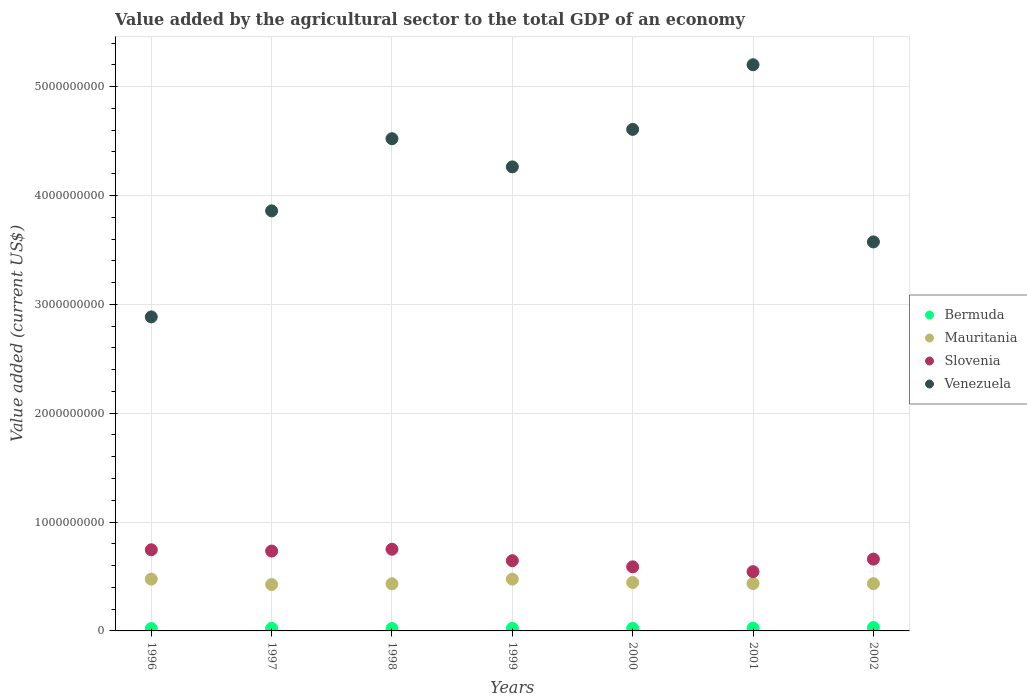What is the value added by the agricultural sector to the total GDP in Venezuela in 1997?
Your answer should be compact. 3.86e+09. Across all years, what is the maximum value added by the agricultural sector to the total GDP in Bermuda?
Your answer should be compact. 3.13e+07. Across all years, what is the minimum value added by the agricultural sector to the total GDP in Mauritania?
Make the answer very short. 4.26e+08. In which year was the value added by the agricultural sector to the total GDP in Bermuda minimum?
Keep it short and to the point. 1996. What is the total value added by the agricultural sector to the total GDP in Mauritania in the graph?
Provide a succinct answer. 3.12e+09. What is the difference between the value added by the agricultural sector to the total GDP in Venezuela in 2000 and that in 2001?
Make the answer very short. -5.94e+08. What is the difference between the value added by the agricultural sector to the total GDP in Bermuda in 2002 and the value added by the agricultural sector to the total GDP in Mauritania in 2000?
Your answer should be compact. -4.13e+08. What is the average value added by the agricultural sector to the total GDP in Bermuda per year?
Your response must be concise. 2.43e+07. In the year 1996, what is the difference between the value added by the agricultural sector to the total GDP in Mauritania and value added by the agricultural sector to the total GDP in Slovenia?
Your answer should be very brief. -2.69e+08. In how many years, is the value added by the agricultural sector to the total GDP in Venezuela greater than 2200000000 US$?
Your response must be concise. 7. What is the ratio of the value added by the agricultural sector to the total GDP in Slovenia in 1997 to that in 2000?
Your answer should be compact. 1.25. Is the value added by the agricultural sector to the total GDP in Mauritania in 2000 less than that in 2002?
Offer a very short reply. No. What is the difference between the highest and the second highest value added by the agricultural sector to the total GDP in Venezuela?
Ensure brevity in your answer.  5.94e+08. What is the difference between the highest and the lowest value added by the agricultural sector to the total GDP in Bermuda?
Make the answer very short. 9.76e+06. Is the sum of the value added by the agricultural sector to the total GDP in Mauritania in 1998 and 2001 greater than the maximum value added by the agricultural sector to the total GDP in Slovenia across all years?
Provide a succinct answer. Yes. Is it the case that in every year, the sum of the value added by the agricultural sector to the total GDP in Bermuda and value added by the agricultural sector to the total GDP in Mauritania  is greater than the sum of value added by the agricultural sector to the total GDP in Venezuela and value added by the agricultural sector to the total GDP in Slovenia?
Your response must be concise. No. Is it the case that in every year, the sum of the value added by the agricultural sector to the total GDP in Venezuela and value added by the agricultural sector to the total GDP in Slovenia  is greater than the value added by the agricultural sector to the total GDP in Mauritania?
Make the answer very short. Yes. Does the value added by the agricultural sector to the total GDP in Bermuda monotonically increase over the years?
Make the answer very short. No. Is the value added by the agricultural sector to the total GDP in Slovenia strictly greater than the value added by the agricultural sector to the total GDP in Bermuda over the years?
Provide a succinct answer. Yes. How many years are there in the graph?
Give a very brief answer. 7. What is the difference between two consecutive major ticks on the Y-axis?
Offer a very short reply. 1.00e+09. Does the graph contain grids?
Your answer should be very brief. Yes. What is the title of the graph?
Provide a succinct answer. Value added by the agricultural sector to the total GDP of an economy. What is the label or title of the Y-axis?
Your response must be concise. Value added (current US$). What is the Value added (current US$) of Bermuda in 1996?
Provide a succinct answer. 2.16e+07. What is the Value added (current US$) of Mauritania in 1996?
Your answer should be very brief. 4.76e+08. What is the Value added (current US$) of Slovenia in 1996?
Your answer should be very brief. 7.45e+08. What is the Value added (current US$) in Venezuela in 1996?
Ensure brevity in your answer.  2.88e+09. What is the Value added (current US$) of Bermuda in 1997?
Your response must be concise. 2.35e+07. What is the Value added (current US$) of Mauritania in 1997?
Provide a succinct answer. 4.26e+08. What is the Value added (current US$) in Slovenia in 1997?
Offer a terse response. 7.34e+08. What is the Value added (current US$) in Venezuela in 1997?
Your answer should be compact. 3.86e+09. What is the Value added (current US$) of Bermuda in 1998?
Ensure brevity in your answer.  2.19e+07. What is the Value added (current US$) of Mauritania in 1998?
Ensure brevity in your answer.  4.33e+08. What is the Value added (current US$) of Slovenia in 1998?
Offer a terse response. 7.50e+08. What is the Value added (current US$) in Venezuela in 1998?
Your answer should be compact. 4.52e+09. What is the Value added (current US$) of Bermuda in 1999?
Your answer should be compact. 2.33e+07. What is the Value added (current US$) in Mauritania in 1999?
Keep it short and to the point. 4.76e+08. What is the Value added (current US$) of Slovenia in 1999?
Your answer should be compact. 6.45e+08. What is the Value added (current US$) of Venezuela in 1999?
Your response must be concise. 4.26e+09. What is the Value added (current US$) in Bermuda in 2000?
Give a very brief answer. 2.33e+07. What is the Value added (current US$) of Mauritania in 2000?
Offer a terse response. 4.45e+08. What is the Value added (current US$) in Slovenia in 2000?
Your answer should be compact. 5.89e+08. What is the Value added (current US$) in Venezuela in 2000?
Your answer should be very brief. 4.61e+09. What is the Value added (current US$) in Bermuda in 2001?
Provide a succinct answer. 2.55e+07. What is the Value added (current US$) of Mauritania in 2001?
Your answer should be compact. 4.35e+08. What is the Value added (current US$) of Slovenia in 2001?
Provide a short and direct response. 5.44e+08. What is the Value added (current US$) of Venezuela in 2001?
Ensure brevity in your answer.  5.20e+09. What is the Value added (current US$) in Bermuda in 2002?
Offer a terse response. 3.13e+07. What is the Value added (current US$) in Mauritania in 2002?
Your response must be concise. 4.34e+08. What is the Value added (current US$) in Slovenia in 2002?
Keep it short and to the point. 6.60e+08. What is the Value added (current US$) of Venezuela in 2002?
Offer a very short reply. 3.57e+09. Across all years, what is the maximum Value added (current US$) in Bermuda?
Provide a short and direct response. 3.13e+07. Across all years, what is the maximum Value added (current US$) in Mauritania?
Your response must be concise. 4.76e+08. Across all years, what is the maximum Value added (current US$) in Slovenia?
Provide a succinct answer. 7.50e+08. Across all years, what is the maximum Value added (current US$) in Venezuela?
Offer a very short reply. 5.20e+09. Across all years, what is the minimum Value added (current US$) in Bermuda?
Provide a short and direct response. 2.16e+07. Across all years, what is the minimum Value added (current US$) in Mauritania?
Your response must be concise. 4.26e+08. Across all years, what is the minimum Value added (current US$) of Slovenia?
Your answer should be compact. 5.44e+08. Across all years, what is the minimum Value added (current US$) in Venezuela?
Offer a very short reply. 2.88e+09. What is the total Value added (current US$) of Bermuda in the graph?
Ensure brevity in your answer.  1.70e+08. What is the total Value added (current US$) of Mauritania in the graph?
Keep it short and to the point. 3.12e+09. What is the total Value added (current US$) in Slovenia in the graph?
Give a very brief answer. 4.67e+09. What is the total Value added (current US$) of Venezuela in the graph?
Give a very brief answer. 2.89e+1. What is the difference between the Value added (current US$) of Bermuda in 1996 and that in 1997?
Your answer should be very brief. -1.90e+06. What is the difference between the Value added (current US$) of Mauritania in 1996 and that in 1997?
Ensure brevity in your answer.  5.00e+07. What is the difference between the Value added (current US$) in Slovenia in 1996 and that in 1997?
Give a very brief answer. 1.16e+07. What is the difference between the Value added (current US$) in Venezuela in 1996 and that in 1997?
Offer a very short reply. -9.74e+08. What is the difference between the Value added (current US$) in Bermuda in 1996 and that in 1998?
Give a very brief answer. -3.52e+05. What is the difference between the Value added (current US$) in Mauritania in 1996 and that in 1998?
Your answer should be very brief. 4.32e+07. What is the difference between the Value added (current US$) of Slovenia in 1996 and that in 1998?
Make the answer very short. -5.19e+06. What is the difference between the Value added (current US$) in Venezuela in 1996 and that in 1998?
Your answer should be very brief. -1.64e+09. What is the difference between the Value added (current US$) in Bermuda in 1996 and that in 1999?
Offer a very short reply. -1.71e+06. What is the difference between the Value added (current US$) of Mauritania in 1996 and that in 1999?
Ensure brevity in your answer.  5.43e+05. What is the difference between the Value added (current US$) of Slovenia in 1996 and that in 1999?
Offer a very short reply. 1.00e+08. What is the difference between the Value added (current US$) of Venezuela in 1996 and that in 1999?
Offer a very short reply. -1.38e+09. What is the difference between the Value added (current US$) in Bermuda in 1996 and that in 2000?
Provide a succinct answer. -1.72e+06. What is the difference between the Value added (current US$) of Mauritania in 1996 and that in 2000?
Provide a succinct answer. 3.15e+07. What is the difference between the Value added (current US$) of Slovenia in 1996 and that in 2000?
Offer a very short reply. 1.57e+08. What is the difference between the Value added (current US$) of Venezuela in 1996 and that in 2000?
Give a very brief answer. -1.72e+09. What is the difference between the Value added (current US$) of Bermuda in 1996 and that in 2001?
Your answer should be very brief. -3.92e+06. What is the difference between the Value added (current US$) in Mauritania in 1996 and that in 2001?
Give a very brief answer. 4.09e+07. What is the difference between the Value added (current US$) in Slovenia in 1996 and that in 2001?
Offer a very short reply. 2.01e+08. What is the difference between the Value added (current US$) of Venezuela in 1996 and that in 2001?
Your answer should be compact. -2.32e+09. What is the difference between the Value added (current US$) of Bermuda in 1996 and that in 2002?
Provide a short and direct response. -9.76e+06. What is the difference between the Value added (current US$) of Mauritania in 1996 and that in 2002?
Make the answer very short. 4.19e+07. What is the difference between the Value added (current US$) of Slovenia in 1996 and that in 2002?
Your answer should be very brief. 8.56e+07. What is the difference between the Value added (current US$) of Venezuela in 1996 and that in 2002?
Your answer should be very brief. -6.89e+08. What is the difference between the Value added (current US$) of Bermuda in 1997 and that in 1998?
Make the answer very short. 1.55e+06. What is the difference between the Value added (current US$) in Mauritania in 1997 and that in 1998?
Give a very brief answer. -6.77e+06. What is the difference between the Value added (current US$) of Slovenia in 1997 and that in 1998?
Give a very brief answer. -1.68e+07. What is the difference between the Value added (current US$) of Venezuela in 1997 and that in 1998?
Your response must be concise. -6.63e+08. What is the difference between the Value added (current US$) in Bermuda in 1997 and that in 1999?
Offer a terse response. 1.92e+05. What is the difference between the Value added (current US$) of Mauritania in 1997 and that in 1999?
Offer a terse response. -4.95e+07. What is the difference between the Value added (current US$) of Slovenia in 1997 and that in 1999?
Offer a very short reply. 8.85e+07. What is the difference between the Value added (current US$) of Venezuela in 1997 and that in 1999?
Keep it short and to the point. -4.04e+08. What is the difference between the Value added (current US$) in Bermuda in 1997 and that in 2000?
Ensure brevity in your answer.  1.82e+05. What is the difference between the Value added (current US$) in Mauritania in 1997 and that in 2000?
Give a very brief answer. -1.85e+07. What is the difference between the Value added (current US$) in Slovenia in 1997 and that in 2000?
Provide a succinct answer. 1.45e+08. What is the difference between the Value added (current US$) in Venezuela in 1997 and that in 2000?
Your response must be concise. -7.49e+08. What is the difference between the Value added (current US$) of Bermuda in 1997 and that in 2001?
Provide a short and direct response. -2.02e+06. What is the difference between the Value added (current US$) in Mauritania in 1997 and that in 2001?
Make the answer very short. -9.14e+06. What is the difference between the Value added (current US$) of Slovenia in 1997 and that in 2001?
Give a very brief answer. 1.89e+08. What is the difference between the Value added (current US$) of Venezuela in 1997 and that in 2001?
Your response must be concise. -1.34e+09. What is the difference between the Value added (current US$) of Bermuda in 1997 and that in 2002?
Your answer should be compact. -7.86e+06. What is the difference between the Value added (current US$) of Mauritania in 1997 and that in 2002?
Your answer should be compact. -8.09e+06. What is the difference between the Value added (current US$) in Slovenia in 1997 and that in 2002?
Give a very brief answer. 7.40e+07. What is the difference between the Value added (current US$) in Venezuela in 1997 and that in 2002?
Your answer should be very brief. 2.85e+08. What is the difference between the Value added (current US$) in Bermuda in 1998 and that in 1999?
Your response must be concise. -1.36e+06. What is the difference between the Value added (current US$) of Mauritania in 1998 and that in 1999?
Provide a succinct answer. -4.27e+07. What is the difference between the Value added (current US$) in Slovenia in 1998 and that in 1999?
Your response must be concise. 1.05e+08. What is the difference between the Value added (current US$) in Venezuela in 1998 and that in 1999?
Keep it short and to the point. 2.59e+08. What is the difference between the Value added (current US$) in Bermuda in 1998 and that in 2000?
Ensure brevity in your answer.  -1.37e+06. What is the difference between the Value added (current US$) in Mauritania in 1998 and that in 2000?
Give a very brief answer. -1.18e+07. What is the difference between the Value added (current US$) of Slovenia in 1998 and that in 2000?
Ensure brevity in your answer.  1.62e+08. What is the difference between the Value added (current US$) of Venezuela in 1998 and that in 2000?
Keep it short and to the point. -8.57e+07. What is the difference between the Value added (current US$) of Bermuda in 1998 and that in 2001?
Offer a very short reply. -3.57e+06. What is the difference between the Value added (current US$) of Mauritania in 1998 and that in 2001?
Provide a short and direct response. -2.37e+06. What is the difference between the Value added (current US$) in Slovenia in 1998 and that in 2001?
Make the answer very short. 2.06e+08. What is the difference between the Value added (current US$) in Venezuela in 1998 and that in 2001?
Offer a very short reply. -6.79e+08. What is the difference between the Value added (current US$) in Bermuda in 1998 and that in 2002?
Offer a terse response. -9.40e+06. What is the difference between the Value added (current US$) in Mauritania in 1998 and that in 2002?
Your response must be concise. -1.32e+06. What is the difference between the Value added (current US$) of Slovenia in 1998 and that in 2002?
Ensure brevity in your answer.  9.08e+07. What is the difference between the Value added (current US$) in Venezuela in 1998 and that in 2002?
Make the answer very short. 9.48e+08. What is the difference between the Value added (current US$) in Bermuda in 1999 and that in 2000?
Your answer should be very brief. -9969. What is the difference between the Value added (current US$) in Mauritania in 1999 and that in 2000?
Provide a short and direct response. 3.09e+07. What is the difference between the Value added (current US$) in Slovenia in 1999 and that in 2000?
Offer a terse response. 5.65e+07. What is the difference between the Value added (current US$) of Venezuela in 1999 and that in 2000?
Offer a very short reply. -3.44e+08. What is the difference between the Value added (current US$) of Bermuda in 1999 and that in 2001?
Make the answer very short. -2.21e+06. What is the difference between the Value added (current US$) of Mauritania in 1999 and that in 2001?
Offer a very short reply. 4.03e+07. What is the difference between the Value added (current US$) of Slovenia in 1999 and that in 2001?
Provide a succinct answer. 1.01e+08. What is the difference between the Value added (current US$) in Venezuela in 1999 and that in 2001?
Ensure brevity in your answer.  -9.38e+08. What is the difference between the Value added (current US$) in Bermuda in 1999 and that in 2002?
Provide a succinct answer. -8.05e+06. What is the difference between the Value added (current US$) of Mauritania in 1999 and that in 2002?
Your response must be concise. 4.14e+07. What is the difference between the Value added (current US$) of Slovenia in 1999 and that in 2002?
Offer a very short reply. -1.45e+07. What is the difference between the Value added (current US$) in Venezuela in 1999 and that in 2002?
Your response must be concise. 6.89e+08. What is the difference between the Value added (current US$) of Bermuda in 2000 and that in 2001?
Give a very brief answer. -2.20e+06. What is the difference between the Value added (current US$) in Mauritania in 2000 and that in 2001?
Offer a very short reply. 9.40e+06. What is the difference between the Value added (current US$) of Slovenia in 2000 and that in 2001?
Keep it short and to the point. 4.43e+07. What is the difference between the Value added (current US$) of Venezuela in 2000 and that in 2001?
Offer a very short reply. -5.94e+08. What is the difference between the Value added (current US$) of Bermuda in 2000 and that in 2002?
Your answer should be very brief. -8.04e+06. What is the difference between the Value added (current US$) in Mauritania in 2000 and that in 2002?
Keep it short and to the point. 1.04e+07. What is the difference between the Value added (current US$) of Slovenia in 2000 and that in 2002?
Your answer should be very brief. -7.10e+07. What is the difference between the Value added (current US$) of Venezuela in 2000 and that in 2002?
Provide a short and direct response. 1.03e+09. What is the difference between the Value added (current US$) of Bermuda in 2001 and that in 2002?
Your response must be concise. -5.84e+06. What is the difference between the Value added (current US$) in Mauritania in 2001 and that in 2002?
Offer a very short reply. 1.05e+06. What is the difference between the Value added (current US$) of Slovenia in 2001 and that in 2002?
Offer a terse response. -1.15e+08. What is the difference between the Value added (current US$) in Venezuela in 2001 and that in 2002?
Ensure brevity in your answer.  1.63e+09. What is the difference between the Value added (current US$) of Bermuda in 1996 and the Value added (current US$) of Mauritania in 1997?
Your answer should be very brief. -4.04e+08. What is the difference between the Value added (current US$) in Bermuda in 1996 and the Value added (current US$) in Slovenia in 1997?
Your answer should be very brief. -7.12e+08. What is the difference between the Value added (current US$) of Bermuda in 1996 and the Value added (current US$) of Venezuela in 1997?
Offer a very short reply. -3.84e+09. What is the difference between the Value added (current US$) in Mauritania in 1996 and the Value added (current US$) in Slovenia in 1997?
Keep it short and to the point. -2.58e+08. What is the difference between the Value added (current US$) of Mauritania in 1996 and the Value added (current US$) of Venezuela in 1997?
Give a very brief answer. -3.38e+09. What is the difference between the Value added (current US$) of Slovenia in 1996 and the Value added (current US$) of Venezuela in 1997?
Your answer should be very brief. -3.11e+09. What is the difference between the Value added (current US$) of Bermuda in 1996 and the Value added (current US$) of Mauritania in 1998?
Provide a succinct answer. -4.11e+08. What is the difference between the Value added (current US$) of Bermuda in 1996 and the Value added (current US$) of Slovenia in 1998?
Your answer should be compact. -7.29e+08. What is the difference between the Value added (current US$) in Bermuda in 1996 and the Value added (current US$) in Venezuela in 1998?
Provide a short and direct response. -4.50e+09. What is the difference between the Value added (current US$) in Mauritania in 1996 and the Value added (current US$) in Slovenia in 1998?
Your answer should be compact. -2.74e+08. What is the difference between the Value added (current US$) of Mauritania in 1996 and the Value added (current US$) of Venezuela in 1998?
Offer a very short reply. -4.05e+09. What is the difference between the Value added (current US$) of Slovenia in 1996 and the Value added (current US$) of Venezuela in 1998?
Make the answer very short. -3.78e+09. What is the difference between the Value added (current US$) in Bermuda in 1996 and the Value added (current US$) in Mauritania in 1999?
Offer a very short reply. -4.54e+08. What is the difference between the Value added (current US$) of Bermuda in 1996 and the Value added (current US$) of Slovenia in 1999?
Provide a short and direct response. -6.24e+08. What is the difference between the Value added (current US$) in Bermuda in 1996 and the Value added (current US$) in Venezuela in 1999?
Offer a terse response. -4.24e+09. What is the difference between the Value added (current US$) of Mauritania in 1996 and the Value added (current US$) of Slovenia in 1999?
Offer a terse response. -1.69e+08. What is the difference between the Value added (current US$) of Mauritania in 1996 and the Value added (current US$) of Venezuela in 1999?
Your answer should be compact. -3.79e+09. What is the difference between the Value added (current US$) of Slovenia in 1996 and the Value added (current US$) of Venezuela in 1999?
Offer a very short reply. -3.52e+09. What is the difference between the Value added (current US$) in Bermuda in 1996 and the Value added (current US$) in Mauritania in 2000?
Give a very brief answer. -4.23e+08. What is the difference between the Value added (current US$) in Bermuda in 1996 and the Value added (current US$) in Slovenia in 2000?
Provide a short and direct response. -5.67e+08. What is the difference between the Value added (current US$) of Bermuda in 1996 and the Value added (current US$) of Venezuela in 2000?
Provide a succinct answer. -4.59e+09. What is the difference between the Value added (current US$) in Mauritania in 1996 and the Value added (current US$) in Slovenia in 2000?
Provide a short and direct response. -1.13e+08. What is the difference between the Value added (current US$) of Mauritania in 1996 and the Value added (current US$) of Venezuela in 2000?
Provide a short and direct response. -4.13e+09. What is the difference between the Value added (current US$) in Slovenia in 1996 and the Value added (current US$) in Venezuela in 2000?
Offer a terse response. -3.86e+09. What is the difference between the Value added (current US$) in Bermuda in 1996 and the Value added (current US$) in Mauritania in 2001?
Offer a terse response. -4.14e+08. What is the difference between the Value added (current US$) of Bermuda in 1996 and the Value added (current US$) of Slovenia in 2001?
Your answer should be compact. -5.23e+08. What is the difference between the Value added (current US$) in Bermuda in 1996 and the Value added (current US$) in Venezuela in 2001?
Offer a very short reply. -5.18e+09. What is the difference between the Value added (current US$) in Mauritania in 1996 and the Value added (current US$) in Slovenia in 2001?
Give a very brief answer. -6.83e+07. What is the difference between the Value added (current US$) in Mauritania in 1996 and the Value added (current US$) in Venezuela in 2001?
Your answer should be very brief. -4.72e+09. What is the difference between the Value added (current US$) of Slovenia in 1996 and the Value added (current US$) of Venezuela in 2001?
Offer a very short reply. -4.46e+09. What is the difference between the Value added (current US$) in Bermuda in 1996 and the Value added (current US$) in Mauritania in 2002?
Ensure brevity in your answer.  -4.13e+08. What is the difference between the Value added (current US$) of Bermuda in 1996 and the Value added (current US$) of Slovenia in 2002?
Make the answer very short. -6.38e+08. What is the difference between the Value added (current US$) in Bermuda in 1996 and the Value added (current US$) in Venezuela in 2002?
Make the answer very short. -3.55e+09. What is the difference between the Value added (current US$) of Mauritania in 1996 and the Value added (current US$) of Slovenia in 2002?
Offer a very short reply. -1.84e+08. What is the difference between the Value added (current US$) of Mauritania in 1996 and the Value added (current US$) of Venezuela in 2002?
Give a very brief answer. -3.10e+09. What is the difference between the Value added (current US$) in Slovenia in 1996 and the Value added (current US$) in Venezuela in 2002?
Keep it short and to the point. -2.83e+09. What is the difference between the Value added (current US$) in Bermuda in 1997 and the Value added (current US$) in Mauritania in 1998?
Ensure brevity in your answer.  -4.09e+08. What is the difference between the Value added (current US$) in Bermuda in 1997 and the Value added (current US$) in Slovenia in 1998?
Provide a succinct answer. -7.27e+08. What is the difference between the Value added (current US$) in Bermuda in 1997 and the Value added (current US$) in Venezuela in 1998?
Keep it short and to the point. -4.50e+09. What is the difference between the Value added (current US$) in Mauritania in 1997 and the Value added (current US$) in Slovenia in 1998?
Your answer should be compact. -3.24e+08. What is the difference between the Value added (current US$) in Mauritania in 1997 and the Value added (current US$) in Venezuela in 1998?
Your response must be concise. -4.10e+09. What is the difference between the Value added (current US$) in Slovenia in 1997 and the Value added (current US$) in Venezuela in 1998?
Offer a terse response. -3.79e+09. What is the difference between the Value added (current US$) in Bermuda in 1997 and the Value added (current US$) in Mauritania in 1999?
Offer a very short reply. -4.52e+08. What is the difference between the Value added (current US$) of Bermuda in 1997 and the Value added (current US$) of Slovenia in 1999?
Provide a succinct answer. -6.22e+08. What is the difference between the Value added (current US$) of Bermuda in 1997 and the Value added (current US$) of Venezuela in 1999?
Provide a succinct answer. -4.24e+09. What is the difference between the Value added (current US$) of Mauritania in 1997 and the Value added (current US$) of Slovenia in 1999?
Offer a terse response. -2.19e+08. What is the difference between the Value added (current US$) of Mauritania in 1997 and the Value added (current US$) of Venezuela in 1999?
Offer a very short reply. -3.84e+09. What is the difference between the Value added (current US$) of Slovenia in 1997 and the Value added (current US$) of Venezuela in 1999?
Your answer should be very brief. -3.53e+09. What is the difference between the Value added (current US$) of Bermuda in 1997 and the Value added (current US$) of Mauritania in 2000?
Your answer should be compact. -4.21e+08. What is the difference between the Value added (current US$) in Bermuda in 1997 and the Value added (current US$) in Slovenia in 2000?
Your answer should be compact. -5.65e+08. What is the difference between the Value added (current US$) of Bermuda in 1997 and the Value added (current US$) of Venezuela in 2000?
Ensure brevity in your answer.  -4.58e+09. What is the difference between the Value added (current US$) of Mauritania in 1997 and the Value added (current US$) of Slovenia in 2000?
Keep it short and to the point. -1.63e+08. What is the difference between the Value added (current US$) in Mauritania in 1997 and the Value added (current US$) in Venezuela in 2000?
Make the answer very short. -4.18e+09. What is the difference between the Value added (current US$) in Slovenia in 1997 and the Value added (current US$) in Venezuela in 2000?
Offer a terse response. -3.87e+09. What is the difference between the Value added (current US$) in Bermuda in 1997 and the Value added (current US$) in Mauritania in 2001?
Offer a terse response. -4.12e+08. What is the difference between the Value added (current US$) of Bermuda in 1997 and the Value added (current US$) of Slovenia in 2001?
Make the answer very short. -5.21e+08. What is the difference between the Value added (current US$) in Bermuda in 1997 and the Value added (current US$) in Venezuela in 2001?
Offer a terse response. -5.18e+09. What is the difference between the Value added (current US$) in Mauritania in 1997 and the Value added (current US$) in Slovenia in 2001?
Provide a succinct answer. -1.18e+08. What is the difference between the Value added (current US$) in Mauritania in 1997 and the Value added (current US$) in Venezuela in 2001?
Your answer should be compact. -4.77e+09. What is the difference between the Value added (current US$) in Slovenia in 1997 and the Value added (current US$) in Venezuela in 2001?
Ensure brevity in your answer.  -4.47e+09. What is the difference between the Value added (current US$) of Bermuda in 1997 and the Value added (current US$) of Mauritania in 2002?
Your answer should be compact. -4.11e+08. What is the difference between the Value added (current US$) in Bermuda in 1997 and the Value added (current US$) in Slovenia in 2002?
Offer a terse response. -6.36e+08. What is the difference between the Value added (current US$) in Bermuda in 1997 and the Value added (current US$) in Venezuela in 2002?
Offer a very short reply. -3.55e+09. What is the difference between the Value added (current US$) in Mauritania in 1997 and the Value added (current US$) in Slovenia in 2002?
Provide a succinct answer. -2.34e+08. What is the difference between the Value added (current US$) in Mauritania in 1997 and the Value added (current US$) in Venezuela in 2002?
Provide a succinct answer. -3.15e+09. What is the difference between the Value added (current US$) of Slovenia in 1997 and the Value added (current US$) of Venezuela in 2002?
Provide a succinct answer. -2.84e+09. What is the difference between the Value added (current US$) of Bermuda in 1998 and the Value added (current US$) of Mauritania in 1999?
Your response must be concise. -4.54e+08. What is the difference between the Value added (current US$) in Bermuda in 1998 and the Value added (current US$) in Slovenia in 1999?
Offer a very short reply. -6.23e+08. What is the difference between the Value added (current US$) in Bermuda in 1998 and the Value added (current US$) in Venezuela in 1999?
Make the answer very short. -4.24e+09. What is the difference between the Value added (current US$) of Mauritania in 1998 and the Value added (current US$) of Slovenia in 1999?
Ensure brevity in your answer.  -2.12e+08. What is the difference between the Value added (current US$) in Mauritania in 1998 and the Value added (current US$) in Venezuela in 1999?
Keep it short and to the point. -3.83e+09. What is the difference between the Value added (current US$) of Slovenia in 1998 and the Value added (current US$) of Venezuela in 1999?
Offer a very short reply. -3.51e+09. What is the difference between the Value added (current US$) in Bermuda in 1998 and the Value added (current US$) in Mauritania in 2000?
Provide a short and direct response. -4.23e+08. What is the difference between the Value added (current US$) of Bermuda in 1998 and the Value added (current US$) of Slovenia in 2000?
Your response must be concise. -5.67e+08. What is the difference between the Value added (current US$) in Bermuda in 1998 and the Value added (current US$) in Venezuela in 2000?
Provide a succinct answer. -4.59e+09. What is the difference between the Value added (current US$) of Mauritania in 1998 and the Value added (current US$) of Slovenia in 2000?
Your answer should be compact. -1.56e+08. What is the difference between the Value added (current US$) of Mauritania in 1998 and the Value added (current US$) of Venezuela in 2000?
Offer a very short reply. -4.17e+09. What is the difference between the Value added (current US$) of Slovenia in 1998 and the Value added (current US$) of Venezuela in 2000?
Your answer should be very brief. -3.86e+09. What is the difference between the Value added (current US$) in Bermuda in 1998 and the Value added (current US$) in Mauritania in 2001?
Offer a terse response. -4.13e+08. What is the difference between the Value added (current US$) in Bermuda in 1998 and the Value added (current US$) in Slovenia in 2001?
Keep it short and to the point. -5.22e+08. What is the difference between the Value added (current US$) of Bermuda in 1998 and the Value added (current US$) of Venezuela in 2001?
Make the answer very short. -5.18e+09. What is the difference between the Value added (current US$) of Mauritania in 1998 and the Value added (current US$) of Slovenia in 2001?
Offer a terse response. -1.12e+08. What is the difference between the Value added (current US$) of Mauritania in 1998 and the Value added (current US$) of Venezuela in 2001?
Make the answer very short. -4.77e+09. What is the difference between the Value added (current US$) in Slovenia in 1998 and the Value added (current US$) in Venezuela in 2001?
Ensure brevity in your answer.  -4.45e+09. What is the difference between the Value added (current US$) of Bermuda in 1998 and the Value added (current US$) of Mauritania in 2002?
Your answer should be very brief. -4.12e+08. What is the difference between the Value added (current US$) of Bermuda in 1998 and the Value added (current US$) of Slovenia in 2002?
Offer a terse response. -6.38e+08. What is the difference between the Value added (current US$) of Bermuda in 1998 and the Value added (current US$) of Venezuela in 2002?
Offer a terse response. -3.55e+09. What is the difference between the Value added (current US$) in Mauritania in 1998 and the Value added (current US$) in Slovenia in 2002?
Keep it short and to the point. -2.27e+08. What is the difference between the Value added (current US$) of Mauritania in 1998 and the Value added (current US$) of Venezuela in 2002?
Provide a succinct answer. -3.14e+09. What is the difference between the Value added (current US$) in Slovenia in 1998 and the Value added (current US$) in Venezuela in 2002?
Ensure brevity in your answer.  -2.82e+09. What is the difference between the Value added (current US$) of Bermuda in 1999 and the Value added (current US$) of Mauritania in 2000?
Offer a very short reply. -4.21e+08. What is the difference between the Value added (current US$) in Bermuda in 1999 and the Value added (current US$) in Slovenia in 2000?
Offer a terse response. -5.65e+08. What is the difference between the Value added (current US$) in Bermuda in 1999 and the Value added (current US$) in Venezuela in 2000?
Provide a short and direct response. -4.58e+09. What is the difference between the Value added (current US$) in Mauritania in 1999 and the Value added (current US$) in Slovenia in 2000?
Keep it short and to the point. -1.13e+08. What is the difference between the Value added (current US$) in Mauritania in 1999 and the Value added (current US$) in Venezuela in 2000?
Your response must be concise. -4.13e+09. What is the difference between the Value added (current US$) of Slovenia in 1999 and the Value added (current US$) of Venezuela in 2000?
Offer a terse response. -3.96e+09. What is the difference between the Value added (current US$) of Bermuda in 1999 and the Value added (current US$) of Mauritania in 2001?
Provide a succinct answer. -4.12e+08. What is the difference between the Value added (current US$) of Bermuda in 1999 and the Value added (current US$) of Slovenia in 2001?
Provide a short and direct response. -5.21e+08. What is the difference between the Value added (current US$) of Bermuda in 1999 and the Value added (current US$) of Venezuela in 2001?
Ensure brevity in your answer.  -5.18e+09. What is the difference between the Value added (current US$) of Mauritania in 1999 and the Value added (current US$) of Slovenia in 2001?
Keep it short and to the point. -6.89e+07. What is the difference between the Value added (current US$) in Mauritania in 1999 and the Value added (current US$) in Venezuela in 2001?
Offer a terse response. -4.73e+09. What is the difference between the Value added (current US$) of Slovenia in 1999 and the Value added (current US$) of Venezuela in 2001?
Make the answer very short. -4.56e+09. What is the difference between the Value added (current US$) in Bermuda in 1999 and the Value added (current US$) in Mauritania in 2002?
Your response must be concise. -4.11e+08. What is the difference between the Value added (current US$) in Bermuda in 1999 and the Value added (current US$) in Slovenia in 2002?
Your answer should be compact. -6.36e+08. What is the difference between the Value added (current US$) of Bermuda in 1999 and the Value added (current US$) of Venezuela in 2002?
Provide a short and direct response. -3.55e+09. What is the difference between the Value added (current US$) in Mauritania in 1999 and the Value added (current US$) in Slovenia in 2002?
Your answer should be compact. -1.84e+08. What is the difference between the Value added (current US$) of Mauritania in 1999 and the Value added (current US$) of Venezuela in 2002?
Give a very brief answer. -3.10e+09. What is the difference between the Value added (current US$) in Slovenia in 1999 and the Value added (current US$) in Venezuela in 2002?
Your response must be concise. -2.93e+09. What is the difference between the Value added (current US$) in Bermuda in 2000 and the Value added (current US$) in Mauritania in 2001?
Your answer should be very brief. -4.12e+08. What is the difference between the Value added (current US$) in Bermuda in 2000 and the Value added (current US$) in Slovenia in 2001?
Your response must be concise. -5.21e+08. What is the difference between the Value added (current US$) in Bermuda in 2000 and the Value added (current US$) in Venezuela in 2001?
Ensure brevity in your answer.  -5.18e+09. What is the difference between the Value added (current US$) in Mauritania in 2000 and the Value added (current US$) in Slovenia in 2001?
Make the answer very short. -9.98e+07. What is the difference between the Value added (current US$) of Mauritania in 2000 and the Value added (current US$) of Venezuela in 2001?
Provide a short and direct response. -4.76e+09. What is the difference between the Value added (current US$) of Slovenia in 2000 and the Value added (current US$) of Venezuela in 2001?
Keep it short and to the point. -4.61e+09. What is the difference between the Value added (current US$) in Bermuda in 2000 and the Value added (current US$) in Mauritania in 2002?
Make the answer very short. -4.11e+08. What is the difference between the Value added (current US$) of Bermuda in 2000 and the Value added (current US$) of Slovenia in 2002?
Provide a succinct answer. -6.36e+08. What is the difference between the Value added (current US$) in Bermuda in 2000 and the Value added (current US$) in Venezuela in 2002?
Provide a succinct answer. -3.55e+09. What is the difference between the Value added (current US$) in Mauritania in 2000 and the Value added (current US$) in Slovenia in 2002?
Make the answer very short. -2.15e+08. What is the difference between the Value added (current US$) of Mauritania in 2000 and the Value added (current US$) of Venezuela in 2002?
Provide a short and direct response. -3.13e+09. What is the difference between the Value added (current US$) of Slovenia in 2000 and the Value added (current US$) of Venezuela in 2002?
Your answer should be very brief. -2.98e+09. What is the difference between the Value added (current US$) in Bermuda in 2001 and the Value added (current US$) in Mauritania in 2002?
Your response must be concise. -4.09e+08. What is the difference between the Value added (current US$) in Bermuda in 2001 and the Value added (current US$) in Slovenia in 2002?
Keep it short and to the point. -6.34e+08. What is the difference between the Value added (current US$) of Bermuda in 2001 and the Value added (current US$) of Venezuela in 2002?
Provide a succinct answer. -3.55e+09. What is the difference between the Value added (current US$) in Mauritania in 2001 and the Value added (current US$) in Slovenia in 2002?
Provide a short and direct response. -2.24e+08. What is the difference between the Value added (current US$) of Mauritania in 2001 and the Value added (current US$) of Venezuela in 2002?
Provide a short and direct response. -3.14e+09. What is the difference between the Value added (current US$) of Slovenia in 2001 and the Value added (current US$) of Venezuela in 2002?
Give a very brief answer. -3.03e+09. What is the average Value added (current US$) in Bermuda per year?
Give a very brief answer. 2.43e+07. What is the average Value added (current US$) in Mauritania per year?
Your answer should be compact. 4.46e+08. What is the average Value added (current US$) of Slovenia per year?
Keep it short and to the point. 6.67e+08. What is the average Value added (current US$) of Venezuela per year?
Offer a very short reply. 4.13e+09. In the year 1996, what is the difference between the Value added (current US$) of Bermuda and Value added (current US$) of Mauritania?
Keep it short and to the point. -4.54e+08. In the year 1996, what is the difference between the Value added (current US$) in Bermuda and Value added (current US$) in Slovenia?
Ensure brevity in your answer.  -7.24e+08. In the year 1996, what is the difference between the Value added (current US$) in Bermuda and Value added (current US$) in Venezuela?
Provide a short and direct response. -2.86e+09. In the year 1996, what is the difference between the Value added (current US$) in Mauritania and Value added (current US$) in Slovenia?
Provide a succinct answer. -2.69e+08. In the year 1996, what is the difference between the Value added (current US$) of Mauritania and Value added (current US$) of Venezuela?
Give a very brief answer. -2.41e+09. In the year 1996, what is the difference between the Value added (current US$) in Slovenia and Value added (current US$) in Venezuela?
Offer a terse response. -2.14e+09. In the year 1997, what is the difference between the Value added (current US$) of Bermuda and Value added (current US$) of Mauritania?
Provide a succinct answer. -4.03e+08. In the year 1997, what is the difference between the Value added (current US$) in Bermuda and Value added (current US$) in Slovenia?
Ensure brevity in your answer.  -7.10e+08. In the year 1997, what is the difference between the Value added (current US$) in Bermuda and Value added (current US$) in Venezuela?
Your answer should be compact. -3.84e+09. In the year 1997, what is the difference between the Value added (current US$) in Mauritania and Value added (current US$) in Slovenia?
Give a very brief answer. -3.08e+08. In the year 1997, what is the difference between the Value added (current US$) of Mauritania and Value added (current US$) of Venezuela?
Your response must be concise. -3.43e+09. In the year 1997, what is the difference between the Value added (current US$) in Slovenia and Value added (current US$) in Venezuela?
Make the answer very short. -3.13e+09. In the year 1998, what is the difference between the Value added (current US$) in Bermuda and Value added (current US$) in Mauritania?
Offer a terse response. -4.11e+08. In the year 1998, what is the difference between the Value added (current US$) of Bermuda and Value added (current US$) of Slovenia?
Your answer should be compact. -7.29e+08. In the year 1998, what is the difference between the Value added (current US$) in Bermuda and Value added (current US$) in Venezuela?
Provide a succinct answer. -4.50e+09. In the year 1998, what is the difference between the Value added (current US$) in Mauritania and Value added (current US$) in Slovenia?
Your response must be concise. -3.18e+08. In the year 1998, what is the difference between the Value added (current US$) in Mauritania and Value added (current US$) in Venezuela?
Your answer should be very brief. -4.09e+09. In the year 1998, what is the difference between the Value added (current US$) in Slovenia and Value added (current US$) in Venezuela?
Offer a terse response. -3.77e+09. In the year 1999, what is the difference between the Value added (current US$) in Bermuda and Value added (current US$) in Mauritania?
Your response must be concise. -4.52e+08. In the year 1999, what is the difference between the Value added (current US$) of Bermuda and Value added (current US$) of Slovenia?
Your answer should be very brief. -6.22e+08. In the year 1999, what is the difference between the Value added (current US$) of Bermuda and Value added (current US$) of Venezuela?
Your answer should be very brief. -4.24e+09. In the year 1999, what is the difference between the Value added (current US$) of Mauritania and Value added (current US$) of Slovenia?
Your answer should be compact. -1.70e+08. In the year 1999, what is the difference between the Value added (current US$) in Mauritania and Value added (current US$) in Venezuela?
Offer a terse response. -3.79e+09. In the year 1999, what is the difference between the Value added (current US$) in Slovenia and Value added (current US$) in Venezuela?
Your response must be concise. -3.62e+09. In the year 2000, what is the difference between the Value added (current US$) of Bermuda and Value added (current US$) of Mauritania?
Provide a succinct answer. -4.21e+08. In the year 2000, what is the difference between the Value added (current US$) of Bermuda and Value added (current US$) of Slovenia?
Make the answer very short. -5.65e+08. In the year 2000, what is the difference between the Value added (current US$) of Bermuda and Value added (current US$) of Venezuela?
Keep it short and to the point. -4.58e+09. In the year 2000, what is the difference between the Value added (current US$) in Mauritania and Value added (current US$) in Slovenia?
Give a very brief answer. -1.44e+08. In the year 2000, what is the difference between the Value added (current US$) of Mauritania and Value added (current US$) of Venezuela?
Your answer should be compact. -4.16e+09. In the year 2000, what is the difference between the Value added (current US$) of Slovenia and Value added (current US$) of Venezuela?
Your answer should be very brief. -4.02e+09. In the year 2001, what is the difference between the Value added (current US$) in Bermuda and Value added (current US$) in Mauritania?
Your answer should be very brief. -4.10e+08. In the year 2001, what is the difference between the Value added (current US$) of Bermuda and Value added (current US$) of Slovenia?
Offer a terse response. -5.19e+08. In the year 2001, what is the difference between the Value added (current US$) in Bermuda and Value added (current US$) in Venezuela?
Provide a short and direct response. -5.18e+09. In the year 2001, what is the difference between the Value added (current US$) of Mauritania and Value added (current US$) of Slovenia?
Give a very brief answer. -1.09e+08. In the year 2001, what is the difference between the Value added (current US$) in Mauritania and Value added (current US$) in Venezuela?
Your answer should be compact. -4.77e+09. In the year 2001, what is the difference between the Value added (current US$) in Slovenia and Value added (current US$) in Venezuela?
Ensure brevity in your answer.  -4.66e+09. In the year 2002, what is the difference between the Value added (current US$) of Bermuda and Value added (current US$) of Mauritania?
Ensure brevity in your answer.  -4.03e+08. In the year 2002, what is the difference between the Value added (current US$) in Bermuda and Value added (current US$) in Slovenia?
Give a very brief answer. -6.28e+08. In the year 2002, what is the difference between the Value added (current US$) in Bermuda and Value added (current US$) in Venezuela?
Keep it short and to the point. -3.54e+09. In the year 2002, what is the difference between the Value added (current US$) in Mauritania and Value added (current US$) in Slovenia?
Provide a short and direct response. -2.26e+08. In the year 2002, what is the difference between the Value added (current US$) of Mauritania and Value added (current US$) of Venezuela?
Make the answer very short. -3.14e+09. In the year 2002, what is the difference between the Value added (current US$) of Slovenia and Value added (current US$) of Venezuela?
Your answer should be compact. -2.91e+09. What is the ratio of the Value added (current US$) in Bermuda in 1996 to that in 1997?
Offer a terse response. 0.92. What is the ratio of the Value added (current US$) of Mauritania in 1996 to that in 1997?
Your answer should be compact. 1.12. What is the ratio of the Value added (current US$) in Slovenia in 1996 to that in 1997?
Offer a very short reply. 1.02. What is the ratio of the Value added (current US$) in Venezuela in 1996 to that in 1997?
Your response must be concise. 0.75. What is the ratio of the Value added (current US$) of Bermuda in 1996 to that in 1998?
Your response must be concise. 0.98. What is the ratio of the Value added (current US$) in Mauritania in 1996 to that in 1998?
Keep it short and to the point. 1.1. What is the ratio of the Value added (current US$) in Slovenia in 1996 to that in 1998?
Your answer should be compact. 0.99. What is the ratio of the Value added (current US$) of Venezuela in 1996 to that in 1998?
Offer a terse response. 0.64. What is the ratio of the Value added (current US$) in Bermuda in 1996 to that in 1999?
Your answer should be compact. 0.93. What is the ratio of the Value added (current US$) of Mauritania in 1996 to that in 1999?
Offer a terse response. 1. What is the ratio of the Value added (current US$) of Slovenia in 1996 to that in 1999?
Provide a short and direct response. 1.16. What is the ratio of the Value added (current US$) of Venezuela in 1996 to that in 1999?
Provide a short and direct response. 0.68. What is the ratio of the Value added (current US$) of Bermuda in 1996 to that in 2000?
Your response must be concise. 0.93. What is the ratio of the Value added (current US$) of Mauritania in 1996 to that in 2000?
Offer a very short reply. 1.07. What is the ratio of the Value added (current US$) of Slovenia in 1996 to that in 2000?
Offer a terse response. 1.27. What is the ratio of the Value added (current US$) in Venezuela in 1996 to that in 2000?
Your response must be concise. 0.63. What is the ratio of the Value added (current US$) of Bermuda in 1996 to that in 2001?
Provide a short and direct response. 0.85. What is the ratio of the Value added (current US$) of Mauritania in 1996 to that in 2001?
Offer a very short reply. 1.09. What is the ratio of the Value added (current US$) in Slovenia in 1996 to that in 2001?
Offer a terse response. 1.37. What is the ratio of the Value added (current US$) of Venezuela in 1996 to that in 2001?
Your answer should be compact. 0.55. What is the ratio of the Value added (current US$) of Bermuda in 1996 to that in 2002?
Offer a terse response. 0.69. What is the ratio of the Value added (current US$) of Mauritania in 1996 to that in 2002?
Your answer should be very brief. 1.1. What is the ratio of the Value added (current US$) of Slovenia in 1996 to that in 2002?
Ensure brevity in your answer.  1.13. What is the ratio of the Value added (current US$) of Venezuela in 1996 to that in 2002?
Offer a terse response. 0.81. What is the ratio of the Value added (current US$) of Bermuda in 1997 to that in 1998?
Provide a short and direct response. 1.07. What is the ratio of the Value added (current US$) in Mauritania in 1997 to that in 1998?
Keep it short and to the point. 0.98. What is the ratio of the Value added (current US$) of Slovenia in 1997 to that in 1998?
Your answer should be very brief. 0.98. What is the ratio of the Value added (current US$) of Venezuela in 1997 to that in 1998?
Offer a very short reply. 0.85. What is the ratio of the Value added (current US$) of Bermuda in 1997 to that in 1999?
Your answer should be very brief. 1.01. What is the ratio of the Value added (current US$) in Mauritania in 1997 to that in 1999?
Offer a very short reply. 0.9. What is the ratio of the Value added (current US$) in Slovenia in 1997 to that in 1999?
Your response must be concise. 1.14. What is the ratio of the Value added (current US$) of Venezuela in 1997 to that in 1999?
Give a very brief answer. 0.91. What is the ratio of the Value added (current US$) in Slovenia in 1997 to that in 2000?
Keep it short and to the point. 1.25. What is the ratio of the Value added (current US$) of Venezuela in 1997 to that in 2000?
Ensure brevity in your answer.  0.84. What is the ratio of the Value added (current US$) of Bermuda in 1997 to that in 2001?
Your response must be concise. 0.92. What is the ratio of the Value added (current US$) of Slovenia in 1997 to that in 2001?
Give a very brief answer. 1.35. What is the ratio of the Value added (current US$) of Venezuela in 1997 to that in 2001?
Keep it short and to the point. 0.74. What is the ratio of the Value added (current US$) of Bermuda in 1997 to that in 2002?
Make the answer very short. 0.75. What is the ratio of the Value added (current US$) in Mauritania in 1997 to that in 2002?
Ensure brevity in your answer.  0.98. What is the ratio of the Value added (current US$) in Slovenia in 1997 to that in 2002?
Provide a succinct answer. 1.11. What is the ratio of the Value added (current US$) in Venezuela in 1997 to that in 2002?
Your response must be concise. 1.08. What is the ratio of the Value added (current US$) of Bermuda in 1998 to that in 1999?
Keep it short and to the point. 0.94. What is the ratio of the Value added (current US$) in Mauritania in 1998 to that in 1999?
Ensure brevity in your answer.  0.91. What is the ratio of the Value added (current US$) of Slovenia in 1998 to that in 1999?
Offer a very short reply. 1.16. What is the ratio of the Value added (current US$) in Venezuela in 1998 to that in 1999?
Your response must be concise. 1.06. What is the ratio of the Value added (current US$) of Bermuda in 1998 to that in 2000?
Keep it short and to the point. 0.94. What is the ratio of the Value added (current US$) of Mauritania in 1998 to that in 2000?
Provide a short and direct response. 0.97. What is the ratio of the Value added (current US$) in Slovenia in 1998 to that in 2000?
Your answer should be compact. 1.27. What is the ratio of the Value added (current US$) in Venezuela in 1998 to that in 2000?
Your response must be concise. 0.98. What is the ratio of the Value added (current US$) in Bermuda in 1998 to that in 2001?
Give a very brief answer. 0.86. What is the ratio of the Value added (current US$) in Slovenia in 1998 to that in 2001?
Offer a terse response. 1.38. What is the ratio of the Value added (current US$) of Venezuela in 1998 to that in 2001?
Your answer should be very brief. 0.87. What is the ratio of the Value added (current US$) in Bermuda in 1998 to that in 2002?
Ensure brevity in your answer.  0.7. What is the ratio of the Value added (current US$) in Slovenia in 1998 to that in 2002?
Keep it short and to the point. 1.14. What is the ratio of the Value added (current US$) in Venezuela in 1998 to that in 2002?
Provide a short and direct response. 1.27. What is the ratio of the Value added (current US$) of Mauritania in 1999 to that in 2000?
Give a very brief answer. 1.07. What is the ratio of the Value added (current US$) of Slovenia in 1999 to that in 2000?
Ensure brevity in your answer.  1.1. What is the ratio of the Value added (current US$) of Venezuela in 1999 to that in 2000?
Give a very brief answer. 0.93. What is the ratio of the Value added (current US$) of Bermuda in 1999 to that in 2001?
Make the answer very short. 0.91. What is the ratio of the Value added (current US$) of Mauritania in 1999 to that in 2001?
Give a very brief answer. 1.09. What is the ratio of the Value added (current US$) of Slovenia in 1999 to that in 2001?
Offer a very short reply. 1.19. What is the ratio of the Value added (current US$) in Venezuela in 1999 to that in 2001?
Provide a short and direct response. 0.82. What is the ratio of the Value added (current US$) in Bermuda in 1999 to that in 2002?
Ensure brevity in your answer.  0.74. What is the ratio of the Value added (current US$) of Mauritania in 1999 to that in 2002?
Offer a very short reply. 1.1. What is the ratio of the Value added (current US$) of Slovenia in 1999 to that in 2002?
Your response must be concise. 0.98. What is the ratio of the Value added (current US$) of Venezuela in 1999 to that in 2002?
Your answer should be compact. 1.19. What is the ratio of the Value added (current US$) of Bermuda in 2000 to that in 2001?
Provide a short and direct response. 0.91. What is the ratio of the Value added (current US$) of Mauritania in 2000 to that in 2001?
Your response must be concise. 1.02. What is the ratio of the Value added (current US$) of Slovenia in 2000 to that in 2001?
Offer a terse response. 1.08. What is the ratio of the Value added (current US$) of Venezuela in 2000 to that in 2001?
Your response must be concise. 0.89. What is the ratio of the Value added (current US$) in Bermuda in 2000 to that in 2002?
Provide a short and direct response. 0.74. What is the ratio of the Value added (current US$) in Mauritania in 2000 to that in 2002?
Your answer should be very brief. 1.02. What is the ratio of the Value added (current US$) in Slovenia in 2000 to that in 2002?
Your answer should be compact. 0.89. What is the ratio of the Value added (current US$) in Venezuela in 2000 to that in 2002?
Offer a very short reply. 1.29. What is the ratio of the Value added (current US$) in Bermuda in 2001 to that in 2002?
Your answer should be very brief. 0.81. What is the ratio of the Value added (current US$) in Mauritania in 2001 to that in 2002?
Ensure brevity in your answer.  1. What is the ratio of the Value added (current US$) of Slovenia in 2001 to that in 2002?
Your answer should be very brief. 0.83. What is the ratio of the Value added (current US$) of Venezuela in 2001 to that in 2002?
Provide a succinct answer. 1.46. What is the difference between the highest and the second highest Value added (current US$) of Bermuda?
Make the answer very short. 5.84e+06. What is the difference between the highest and the second highest Value added (current US$) in Mauritania?
Offer a very short reply. 5.43e+05. What is the difference between the highest and the second highest Value added (current US$) in Slovenia?
Provide a succinct answer. 5.19e+06. What is the difference between the highest and the second highest Value added (current US$) in Venezuela?
Give a very brief answer. 5.94e+08. What is the difference between the highest and the lowest Value added (current US$) in Bermuda?
Your response must be concise. 9.76e+06. What is the difference between the highest and the lowest Value added (current US$) of Mauritania?
Your answer should be compact. 5.00e+07. What is the difference between the highest and the lowest Value added (current US$) in Slovenia?
Provide a succinct answer. 2.06e+08. What is the difference between the highest and the lowest Value added (current US$) in Venezuela?
Keep it short and to the point. 2.32e+09. 